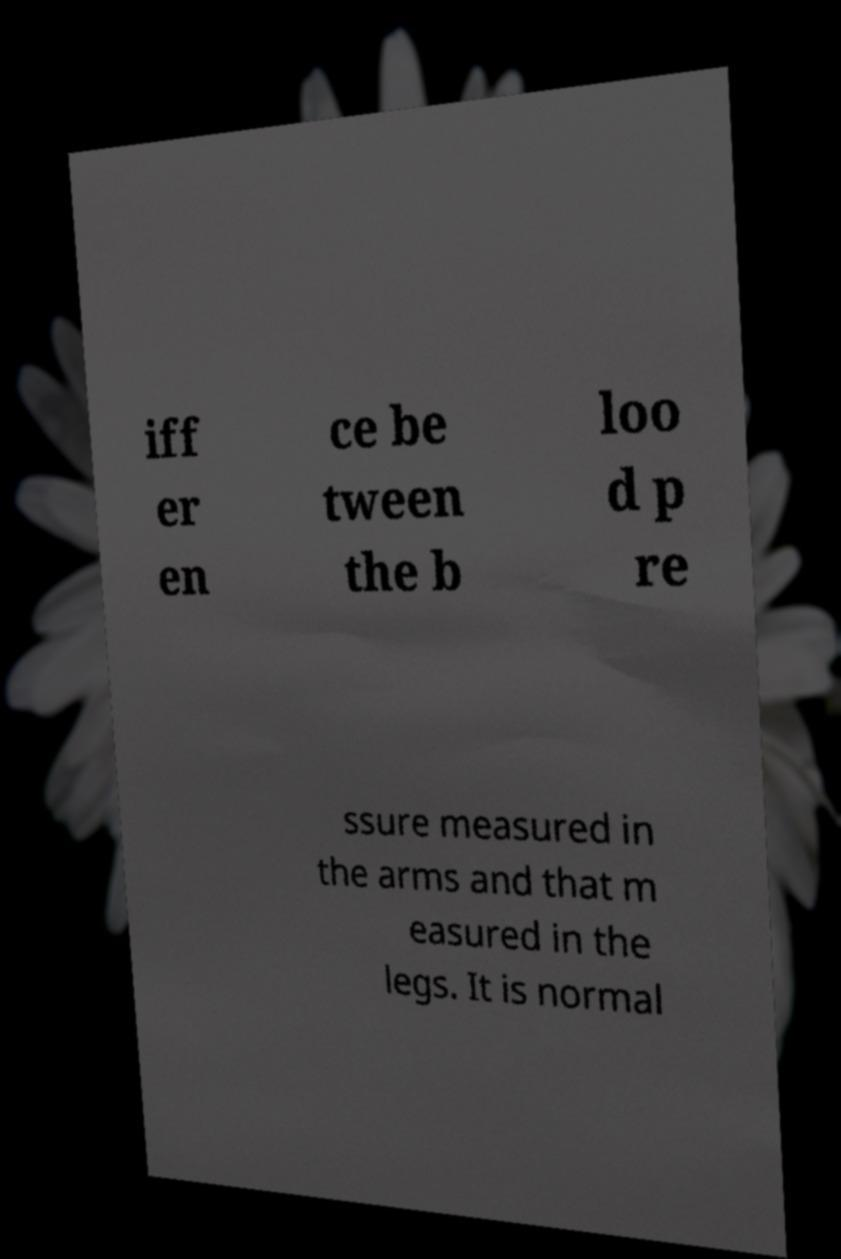Could you extract and type out the text from this image? iff er en ce be tween the b loo d p re ssure measured in the arms and that m easured in the legs. It is normal 